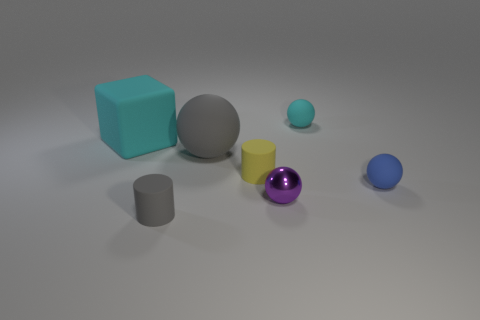Is the number of purple objects on the left side of the tiny metallic object greater than the number of tiny things?
Make the answer very short. No. What number of brown metallic cylinders have the same size as the gray cylinder?
Make the answer very short. 0. Do the matte cylinder that is to the right of the big gray sphere and the matte thing in front of the blue sphere have the same size?
Provide a short and direct response. Yes. Is the number of things to the left of the matte block greater than the number of gray spheres in front of the tiny purple object?
Your response must be concise. No. How many large rubber objects are the same shape as the purple shiny object?
Keep it short and to the point. 1. There is a gray object that is the same size as the purple metal ball; what is its material?
Ensure brevity in your answer.  Rubber. Are there any other gray objects made of the same material as the large gray thing?
Offer a very short reply. Yes. Are there fewer big cyan matte blocks behind the large block than large gray matte things?
Your response must be concise. Yes. There is a thing that is to the right of the cyan matte thing right of the cyan matte block; what is it made of?
Provide a succinct answer. Rubber. What is the shape of the rubber thing that is on the left side of the gray sphere and on the right side of the big cyan matte object?
Your answer should be compact. Cylinder. 